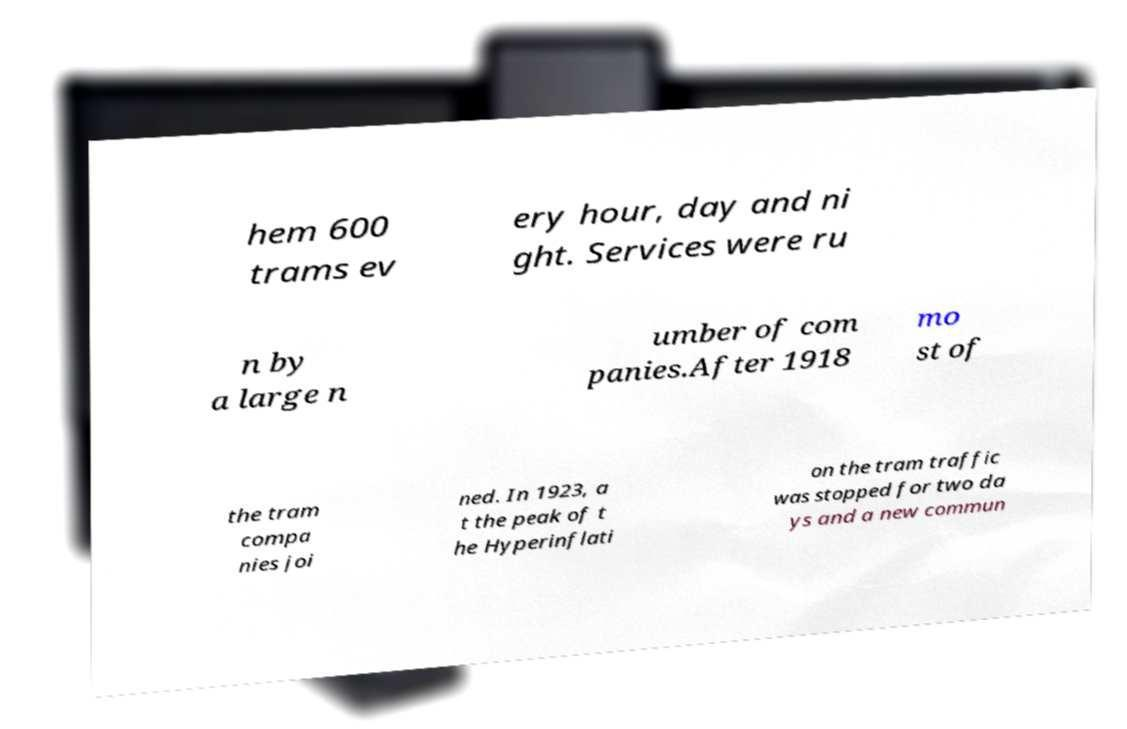Could you extract and type out the text from this image? hem 600 trams ev ery hour, day and ni ght. Services were ru n by a large n umber of com panies.After 1918 mo st of the tram compa nies joi ned. In 1923, a t the peak of t he Hyperinflati on the tram traffic was stopped for two da ys and a new commun 